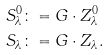<formula> <loc_0><loc_0><loc_500><loc_500>S _ { \lambda } ^ { 0 } & \colon = G \cdot Z _ { \lambda } ^ { 0 } \\ S _ { \lambda } & \colon = G \cdot Z _ { \lambda } .</formula> 